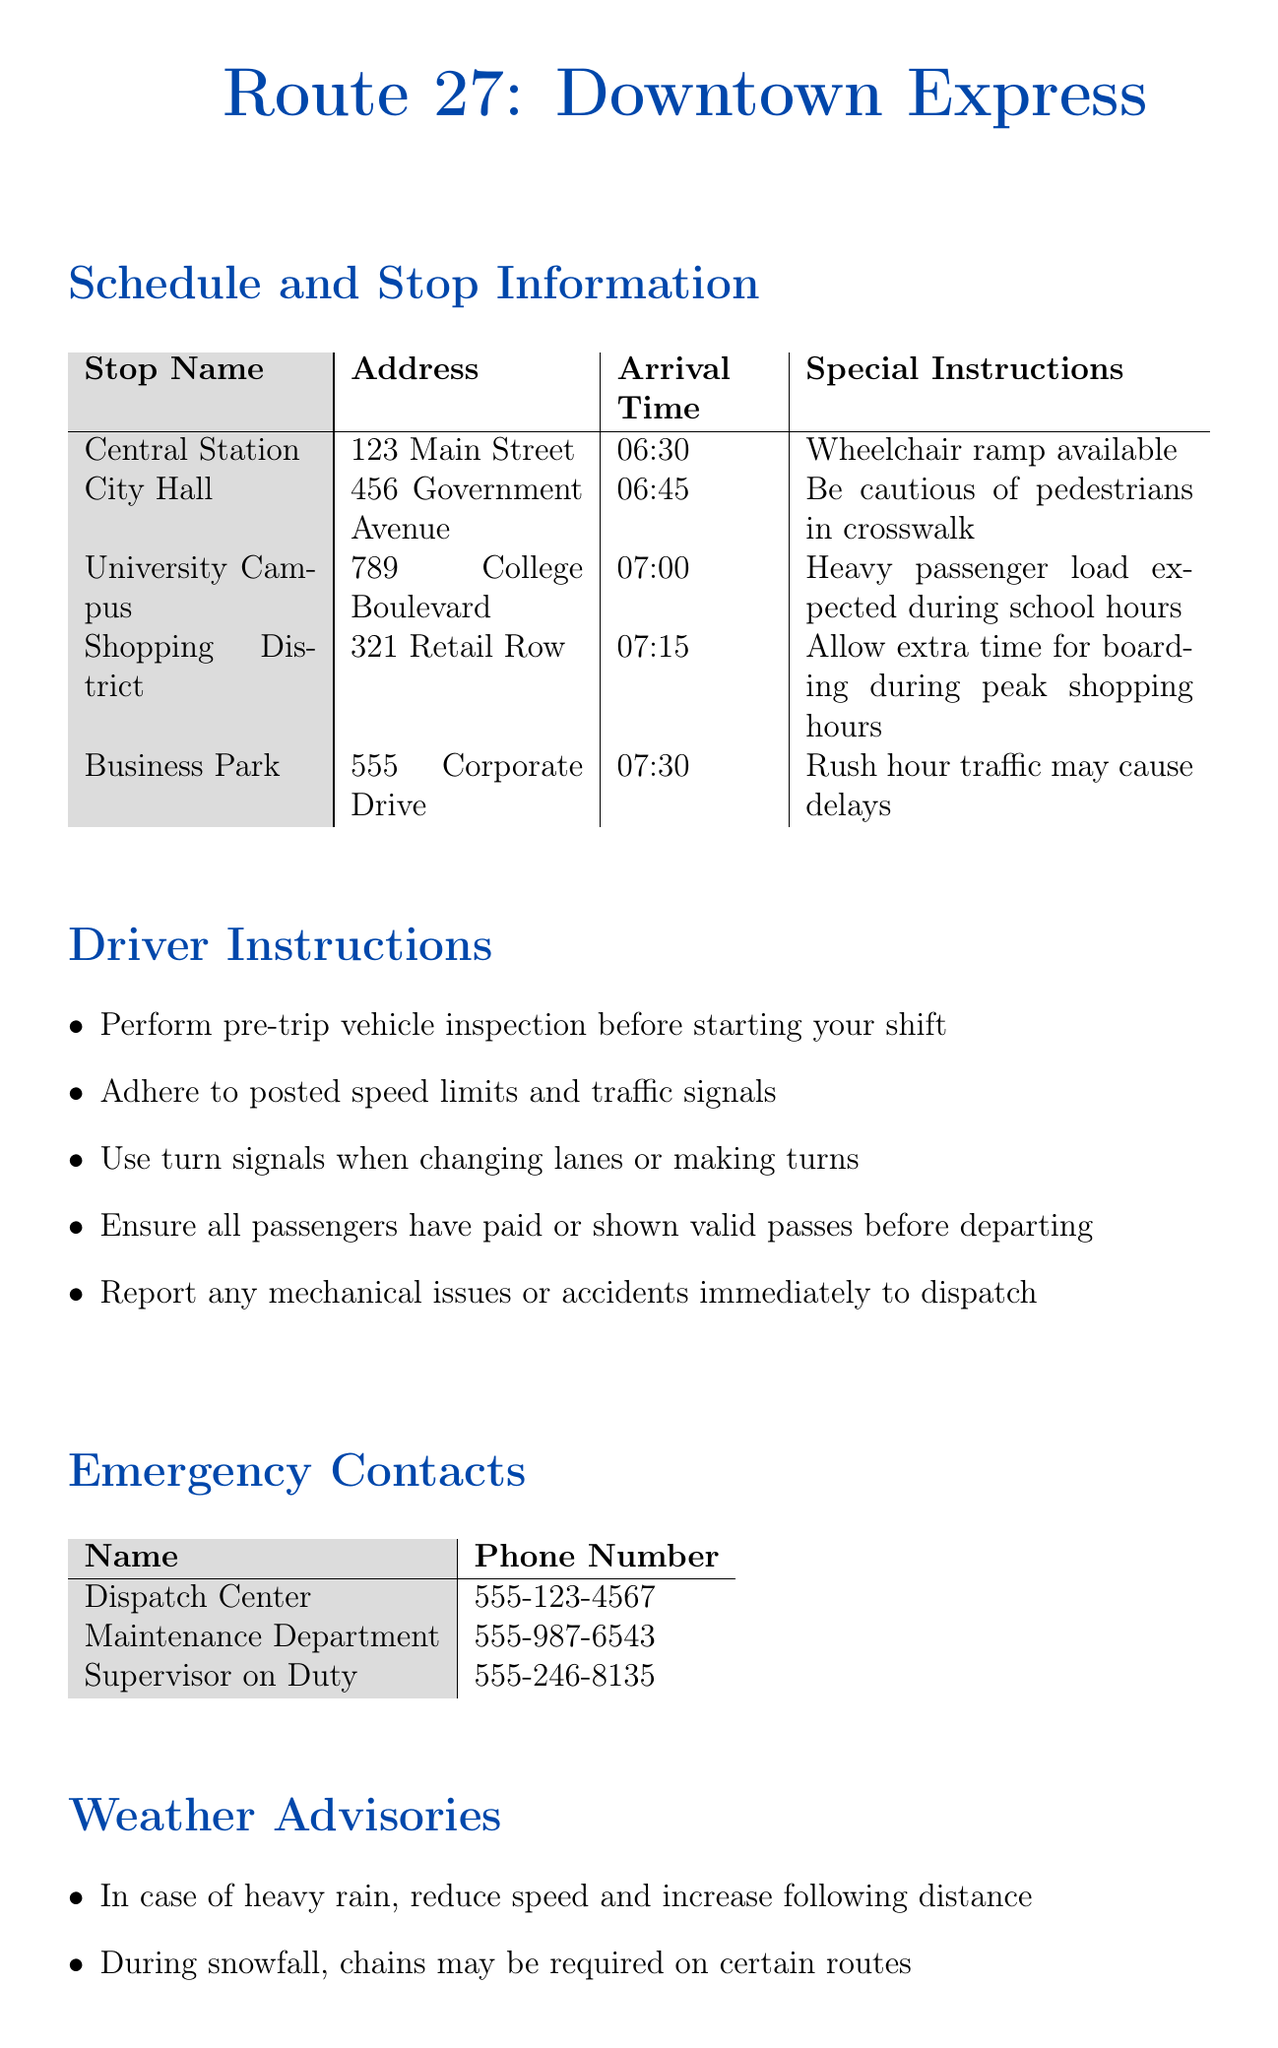what is the route number? The route number is specified at the beginning of the document for the Downtown Express route.
Answer: 27 what is the address of the City Hall stop? The address for City Hall is provided in the schedule section of the document.
Answer: 456 Government Avenue what time does the bus arrive at the Shopping District? The arrival time for Shopping District is explicitly listed in the schedule section.
Answer: 07:15 what special instruction is noted for the University Campus stop? The special instruction for University Campus is mentioned in the schedule section under special instructions.
Answer: Heavy passenger load expected during school hours how many stops are listed in the route schedule? The number of stops can be determined by counting the entries in the schedule section.
Answer: 5 which stop has a wheelchair ramp available? The stop with a wheelchair ramp is identified in the special instructions of the schedule section.
Answer: Central Station what should a driver do before starting their shift? The driver instructions include specific actions to be taken before the shift begins.
Answer: Perform pre-trip vehicle inspection during which event will Route 27 be detoured? The special events section includes details about events affecting the route, including a detour.
Answer: Downtown Street Fair in case of heavy rain, what should a driver do? Weather advisories indicate particular actions to take during adverse weather conditions.
Answer: Reduce speed and increase following distance 